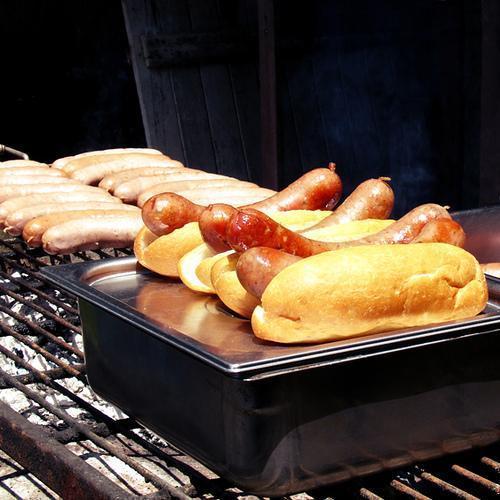How many hot dogs are ready to eat?
Give a very brief answer. 4. How many hot dogs can you see?
Give a very brief answer. 7. 